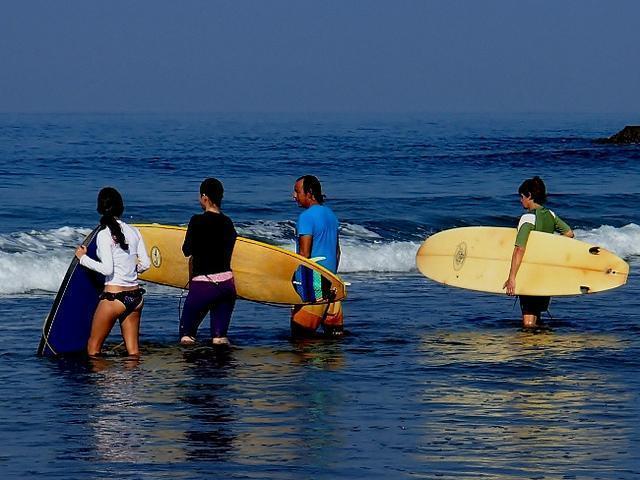How many boards are shown?
Give a very brief answer. 3. How many boards are there?
Give a very brief answer. 3. How many people are there?
Give a very brief answer. 4. How many surfboards are visible?
Give a very brief answer. 3. How many yellow taxi cars are in this image?
Give a very brief answer. 0. 